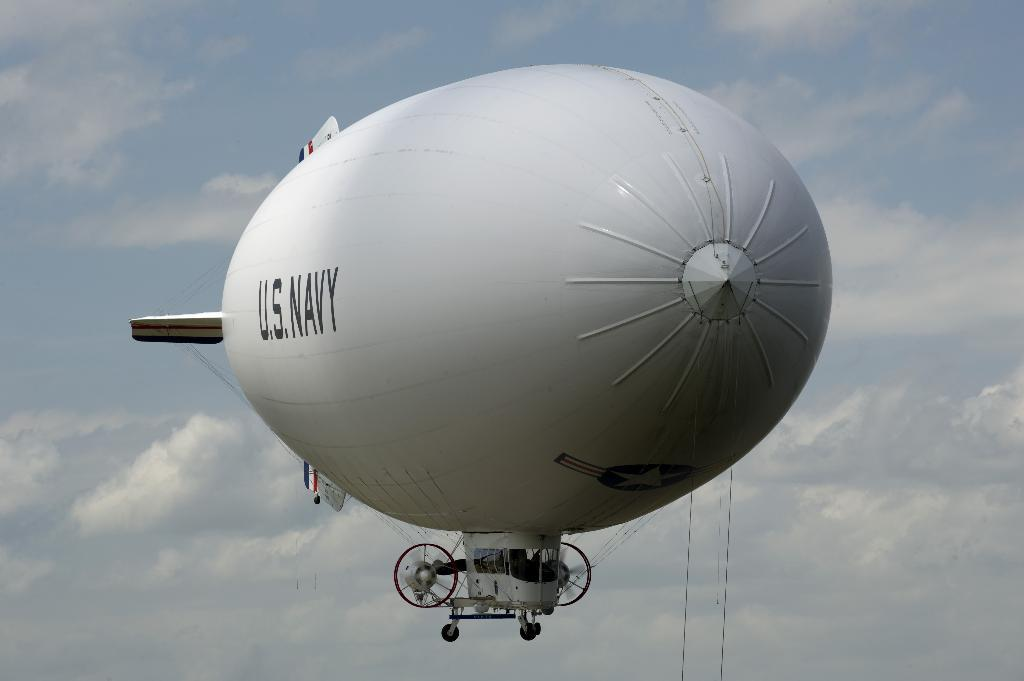<image>
Offer a succinct explanation of the picture presented. A giant air blimp that says U.S. Navy is floating through the sky. 